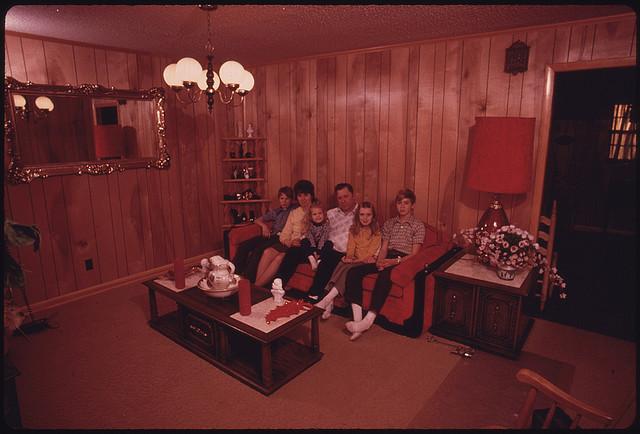Are these heat lamps?
Quick response, please. No. Where is a potted plant in a white pot?
Short answer required. End table. What is on the coffee table?
Give a very brief answer. Cups. Are those Christmas lights?
Answer briefly. No. What are these?
Short answer required. People. What do the audience members feel in this moment?
Answer briefly. Bored. Are there a lot of empty chairs?
Write a very short answer. No. Is this an oriental shop?
Keep it brief. No. Is this place messy?
Write a very short answer. No. Is this person wearing shoes?
Write a very short answer. No. Is the lamp on the end table on?
Be succinct. No. How many people are on the couch?
Concise answer only. 6. What room is this?
Keep it brief. Living room. What type of device are the people in the front row looking at?
Short answer required. Tv. Does this wall need painted?
Concise answer only. No. Are there many clocks in the picture?
Be succinct. No. Was this photo likely taken in the 21st century?
Give a very brief answer. No. How many trunks are near the man?
Give a very brief answer. 0. 